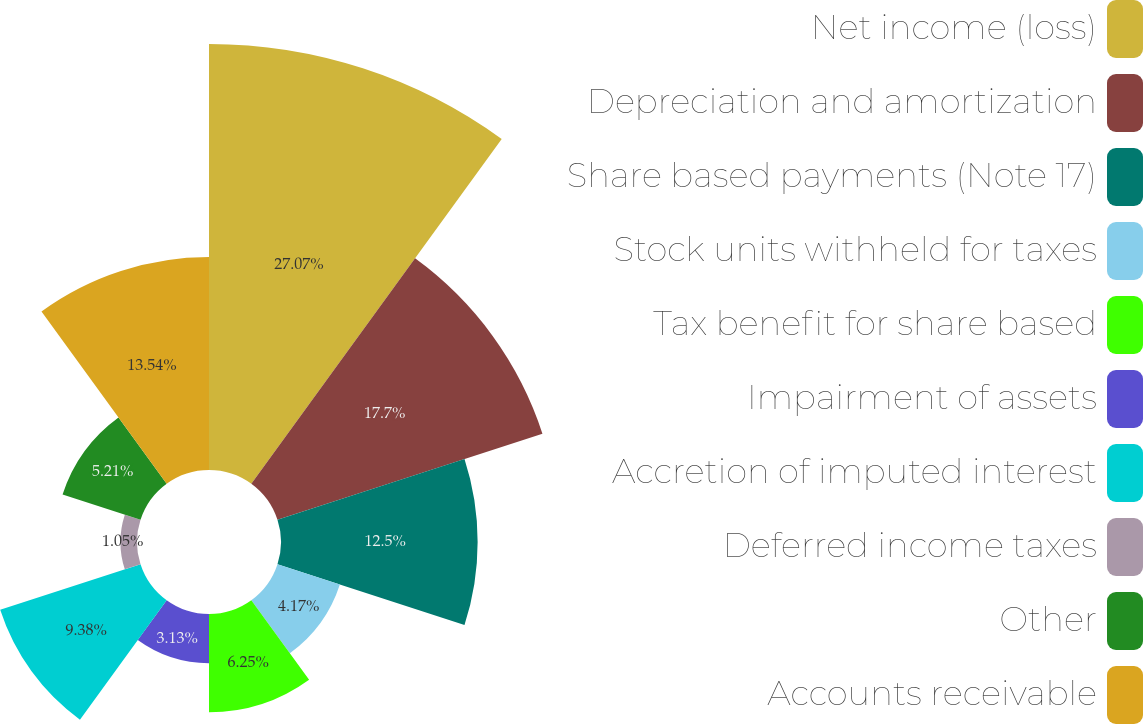Convert chart. <chart><loc_0><loc_0><loc_500><loc_500><pie_chart><fcel>Net income (loss)<fcel>Depreciation and amortization<fcel>Share based payments (Note 17)<fcel>Stock units withheld for taxes<fcel>Tax benefit for share based<fcel>Impairment of assets<fcel>Accretion of imputed interest<fcel>Deferred income taxes<fcel>Other<fcel>Accounts receivable<nl><fcel>27.08%<fcel>17.71%<fcel>12.5%<fcel>4.17%<fcel>6.25%<fcel>3.13%<fcel>9.38%<fcel>1.05%<fcel>5.21%<fcel>13.54%<nl></chart> 